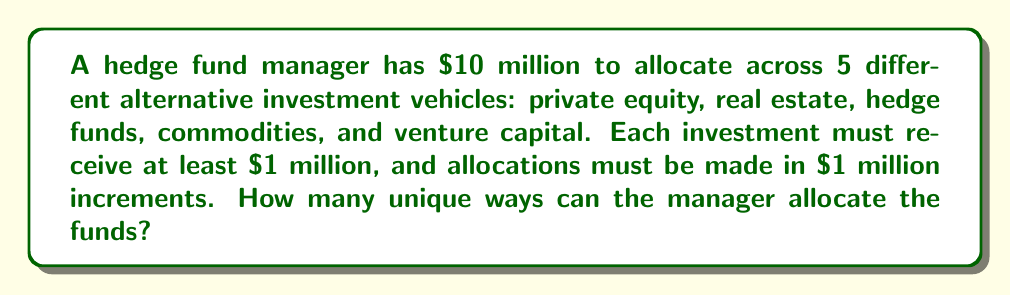Solve this math problem. Let's approach this step-by-step:

1) First, we need to recognize that this is a stars and bars problem. We are distributing indistinguishable objects (the $10 million) into distinguishable containers (the 5 investment vehicles).

2) However, there's a constraint: each investment must receive at least $1 million. To account for this, we can first allocate $1 million to each investment, leaving us with $5 million to distribute freely.

3) Now we have 5 million to distribute among 5 investments, with no minimum requirement. This is a classic stars and bars problem.

4) The formula for stars and bars is:

   $$\binom{n+k-1}{k-1}$$

   where $n$ is the number of indistinguishable objects and $k$ is the number of distinguishable containers.

5) In our case, $n = 5$ (the remaining $5 million to distribute) and $k = 5$ (the 5 investment vehicles).

6) Plugging into the formula:

   $$\binom{5+5-1}{5-1} = \binom{9}{4}$$

7) We can calculate this:

   $$\binom{9}{4} = \frac{9!}{4!(9-4)!} = \frac{9!}{4!5!} = 126$$

Therefore, there are 126 unique ways to allocate the funds.
Answer: 126 